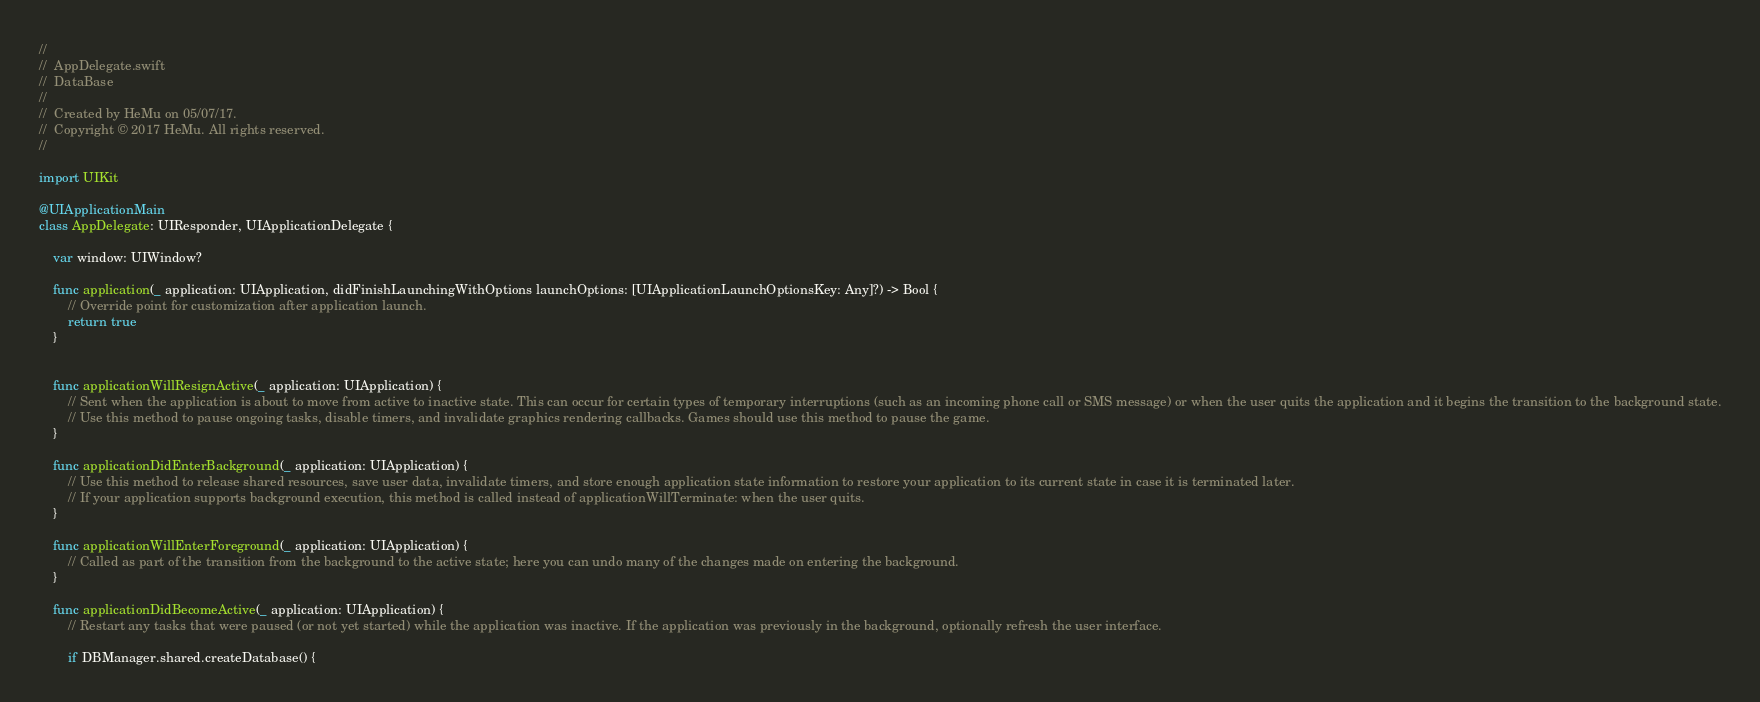Convert code to text. <code><loc_0><loc_0><loc_500><loc_500><_Swift_>//
//  AppDelegate.swift
//  DataBase
//
//  Created by HeMu on 05/07/17.
//  Copyright © 2017 HeMu. All rights reserved.
//

import UIKit

@UIApplicationMain
class AppDelegate: UIResponder, UIApplicationDelegate {

    var window: UIWindow?

    func application(_ application: UIApplication, didFinishLaunchingWithOptions launchOptions: [UIApplicationLaunchOptionsKey: Any]?) -> Bool {
        // Override point for customization after application launch.
        return true
    }

    
    func applicationWillResignActive(_ application: UIApplication) {
        // Sent when the application is about to move from active to inactive state. This can occur for certain types of temporary interruptions (such as an incoming phone call or SMS message) or when the user quits the application and it begins the transition to the background state.
        // Use this method to pause ongoing tasks, disable timers, and invalidate graphics rendering callbacks. Games should use this method to pause the game.
    }

    func applicationDidEnterBackground(_ application: UIApplication) {
        // Use this method to release shared resources, save user data, invalidate timers, and store enough application state information to restore your application to its current state in case it is terminated later.
        // If your application supports background execution, this method is called instead of applicationWillTerminate: when the user quits.
    }

    func applicationWillEnterForeground(_ application: UIApplication) {
        // Called as part of the transition from the background to the active state; here you can undo many of the changes made on entering the background.
    }

    func applicationDidBecomeActive(_ application: UIApplication) {
        // Restart any tasks that were paused (or not yet started) while the application was inactive. If the application was previously in the background, optionally refresh the user interface.
        
        if DBManager.shared.createDatabase() {</code> 